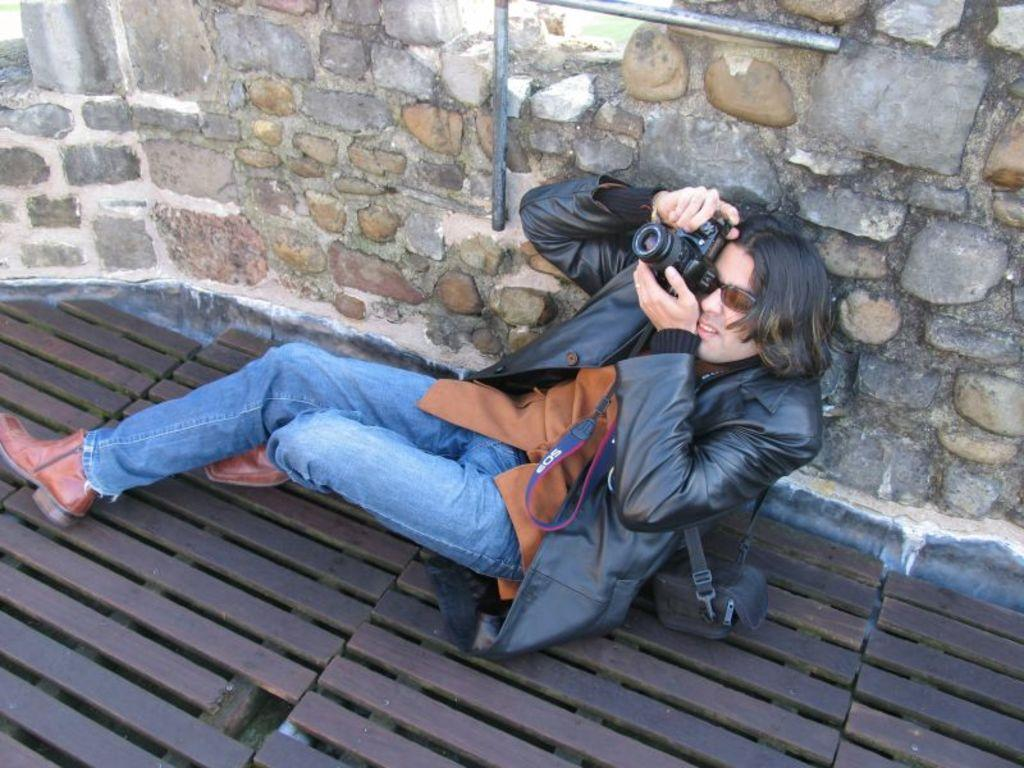What is the person in the image doing? The person is sitting in the image and holding a camera. What can be seen in the background of the image? There is a wall in the background of the image. What material is at the bottom of the image? There is wood at the bottom of the image. What type of punishment is being administered to the person in the image? There is no indication of punishment in the image; the person is simply sitting and holding a camera. 